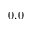<formula> <loc_0><loc_0><loc_500><loc_500>0 . 0</formula> 